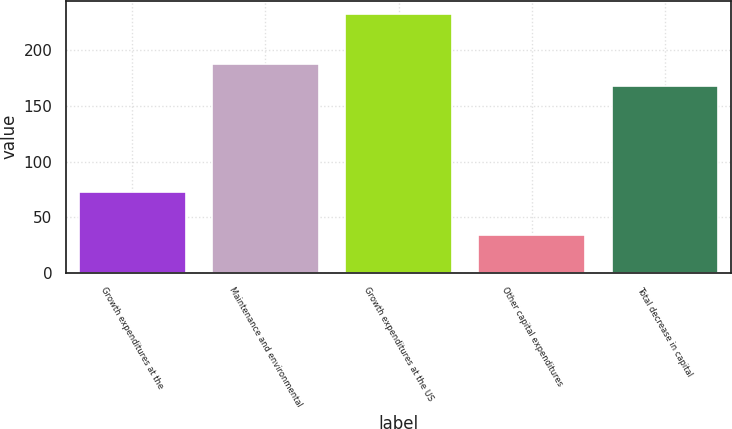Convert chart. <chart><loc_0><loc_0><loc_500><loc_500><bar_chart><fcel>Growth expenditures at the<fcel>Maintenance and environmental<fcel>Growth expenditures at the US<fcel>Other capital expenditures<fcel>Total decrease in capital<nl><fcel>73<fcel>187.9<fcel>233<fcel>34<fcel>168<nl></chart> 